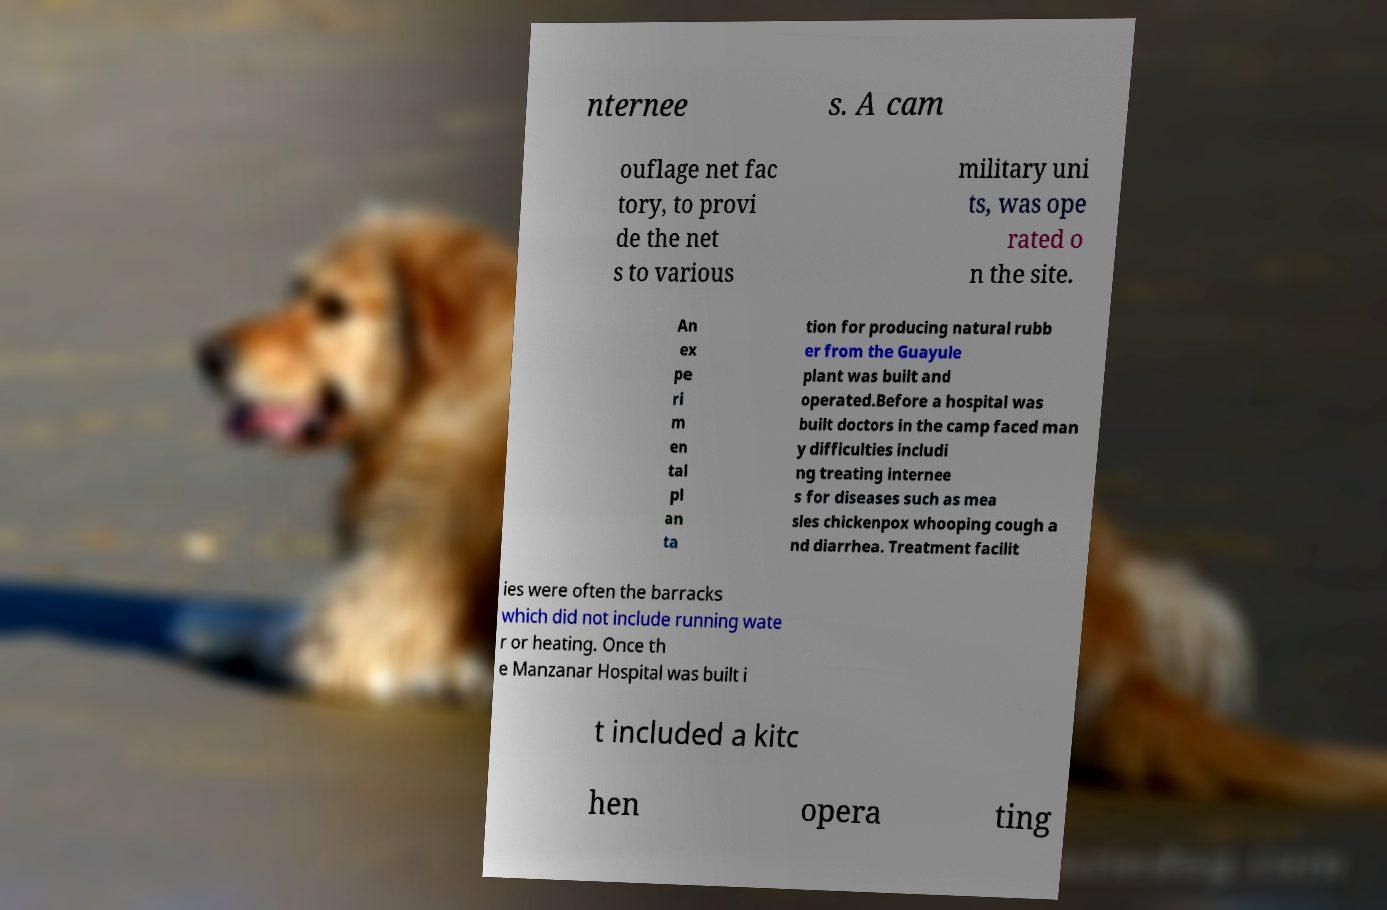Could you extract and type out the text from this image? nternee s. A cam ouflage net fac tory, to provi de the net s to various military uni ts, was ope rated o n the site. An ex pe ri m en tal pl an ta tion for producing natural rubb er from the Guayule plant was built and operated.Before a hospital was built doctors in the camp faced man y difficulties includi ng treating internee s for diseases such as mea sles chickenpox whooping cough a nd diarrhea. Treatment facilit ies were often the barracks which did not include running wate r or heating. Once th e Manzanar Hospital was built i t included a kitc hen opera ting 